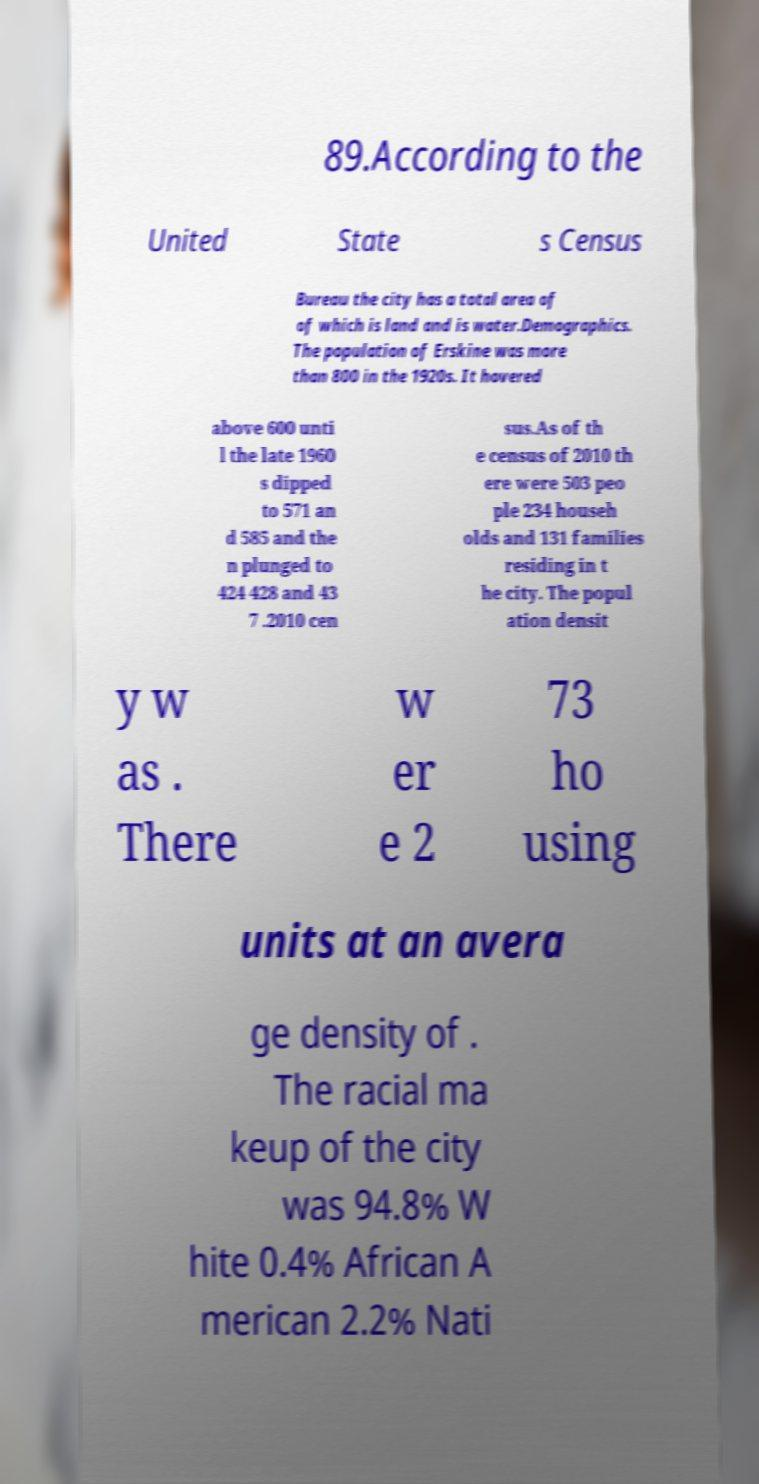There's text embedded in this image that I need extracted. Can you transcribe it verbatim? 89.According to the United State s Census Bureau the city has a total area of of which is land and is water.Demographics. The population of Erskine was more than 800 in the 1920s. It hovered above 600 unti l the late 1960 s dipped to 571 an d 585 and the n plunged to 424 428 and 43 7 .2010 cen sus.As of th e census of 2010 th ere were 503 peo ple 234 househ olds and 131 families residing in t he city. The popul ation densit y w as . There w er e 2 73 ho using units at an avera ge density of . The racial ma keup of the city was 94.8% W hite 0.4% African A merican 2.2% Nati 